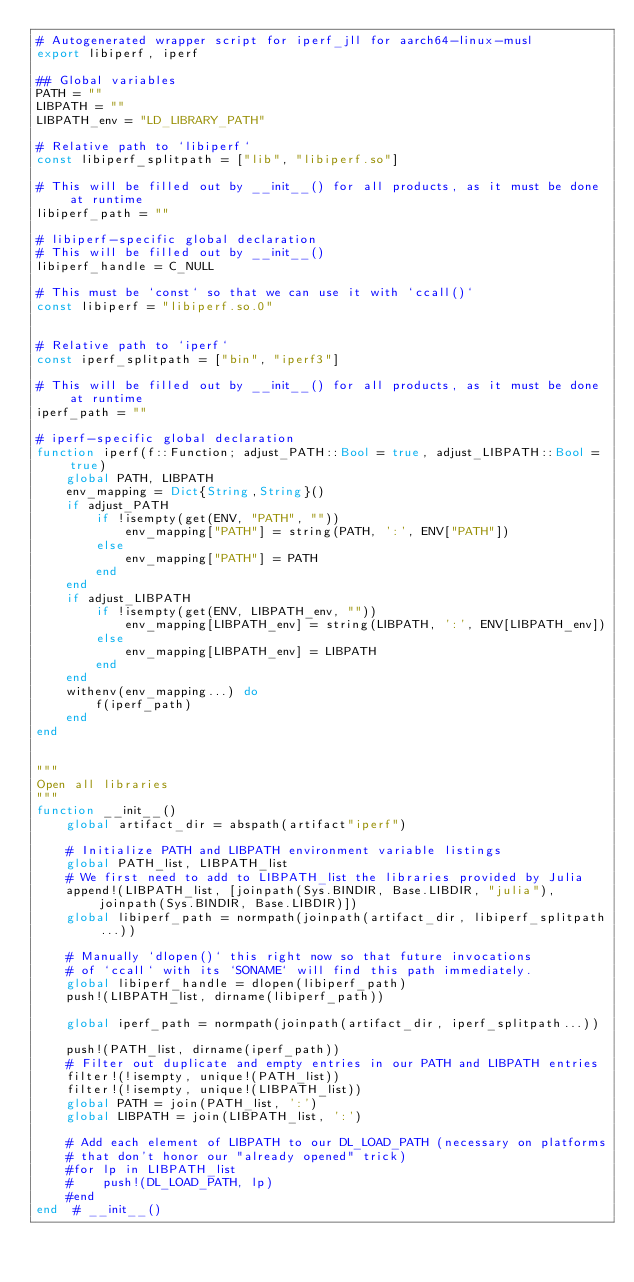<code> <loc_0><loc_0><loc_500><loc_500><_Julia_># Autogenerated wrapper script for iperf_jll for aarch64-linux-musl
export libiperf, iperf

## Global variables
PATH = ""
LIBPATH = ""
LIBPATH_env = "LD_LIBRARY_PATH"

# Relative path to `libiperf`
const libiperf_splitpath = ["lib", "libiperf.so"]

# This will be filled out by __init__() for all products, as it must be done at runtime
libiperf_path = ""

# libiperf-specific global declaration
# This will be filled out by __init__()
libiperf_handle = C_NULL

# This must be `const` so that we can use it with `ccall()`
const libiperf = "libiperf.so.0"


# Relative path to `iperf`
const iperf_splitpath = ["bin", "iperf3"]

# This will be filled out by __init__() for all products, as it must be done at runtime
iperf_path = ""

# iperf-specific global declaration
function iperf(f::Function; adjust_PATH::Bool = true, adjust_LIBPATH::Bool = true)
    global PATH, LIBPATH
    env_mapping = Dict{String,String}()
    if adjust_PATH
        if !isempty(get(ENV, "PATH", ""))
            env_mapping["PATH"] = string(PATH, ':', ENV["PATH"])
        else
            env_mapping["PATH"] = PATH
        end
    end
    if adjust_LIBPATH
        if !isempty(get(ENV, LIBPATH_env, ""))
            env_mapping[LIBPATH_env] = string(LIBPATH, ':', ENV[LIBPATH_env])
        else
            env_mapping[LIBPATH_env] = LIBPATH
        end
    end
    withenv(env_mapping...) do
        f(iperf_path)
    end
end


"""
Open all libraries
"""
function __init__()
    global artifact_dir = abspath(artifact"iperf")

    # Initialize PATH and LIBPATH environment variable listings
    global PATH_list, LIBPATH_list
    # We first need to add to LIBPATH_list the libraries provided by Julia
    append!(LIBPATH_list, [joinpath(Sys.BINDIR, Base.LIBDIR, "julia"), joinpath(Sys.BINDIR, Base.LIBDIR)])
    global libiperf_path = normpath(joinpath(artifact_dir, libiperf_splitpath...))

    # Manually `dlopen()` this right now so that future invocations
    # of `ccall` with its `SONAME` will find this path immediately.
    global libiperf_handle = dlopen(libiperf_path)
    push!(LIBPATH_list, dirname(libiperf_path))

    global iperf_path = normpath(joinpath(artifact_dir, iperf_splitpath...))

    push!(PATH_list, dirname(iperf_path))
    # Filter out duplicate and empty entries in our PATH and LIBPATH entries
    filter!(!isempty, unique!(PATH_list))
    filter!(!isempty, unique!(LIBPATH_list))
    global PATH = join(PATH_list, ':')
    global LIBPATH = join(LIBPATH_list, ':')

    # Add each element of LIBPATH to our DL_LOAD_PATH (necessary on platforms
    # that don't honor our "already opened" trick)
    #for lp in LIBPATH_list
    #    push!(DL_LOAD_PATH, lp)
    #end
end  # __init__()

</code> 